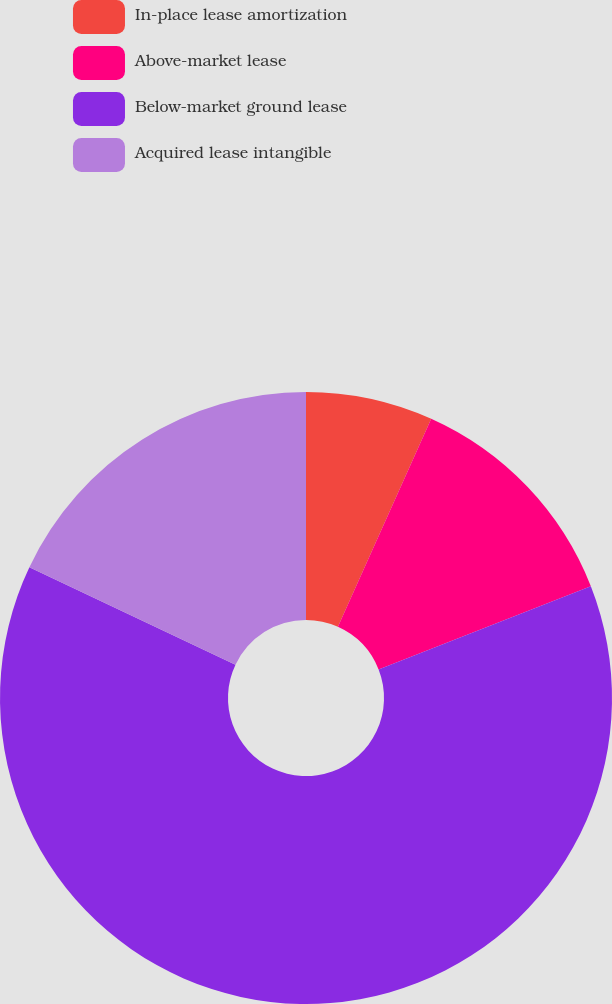Convert chart. <chart><loc_0><loc_0><loc_500><loc_500><pie_chart><fcel>In-place lease amortization<fcel>Above-market lease<fcel>Below-market ground lease<fcel>Acquired lease intangible<nl><fcel>6.71%<fcel>12.34%<fcel>62.99%<fcel>17.97%<nl></chart> 